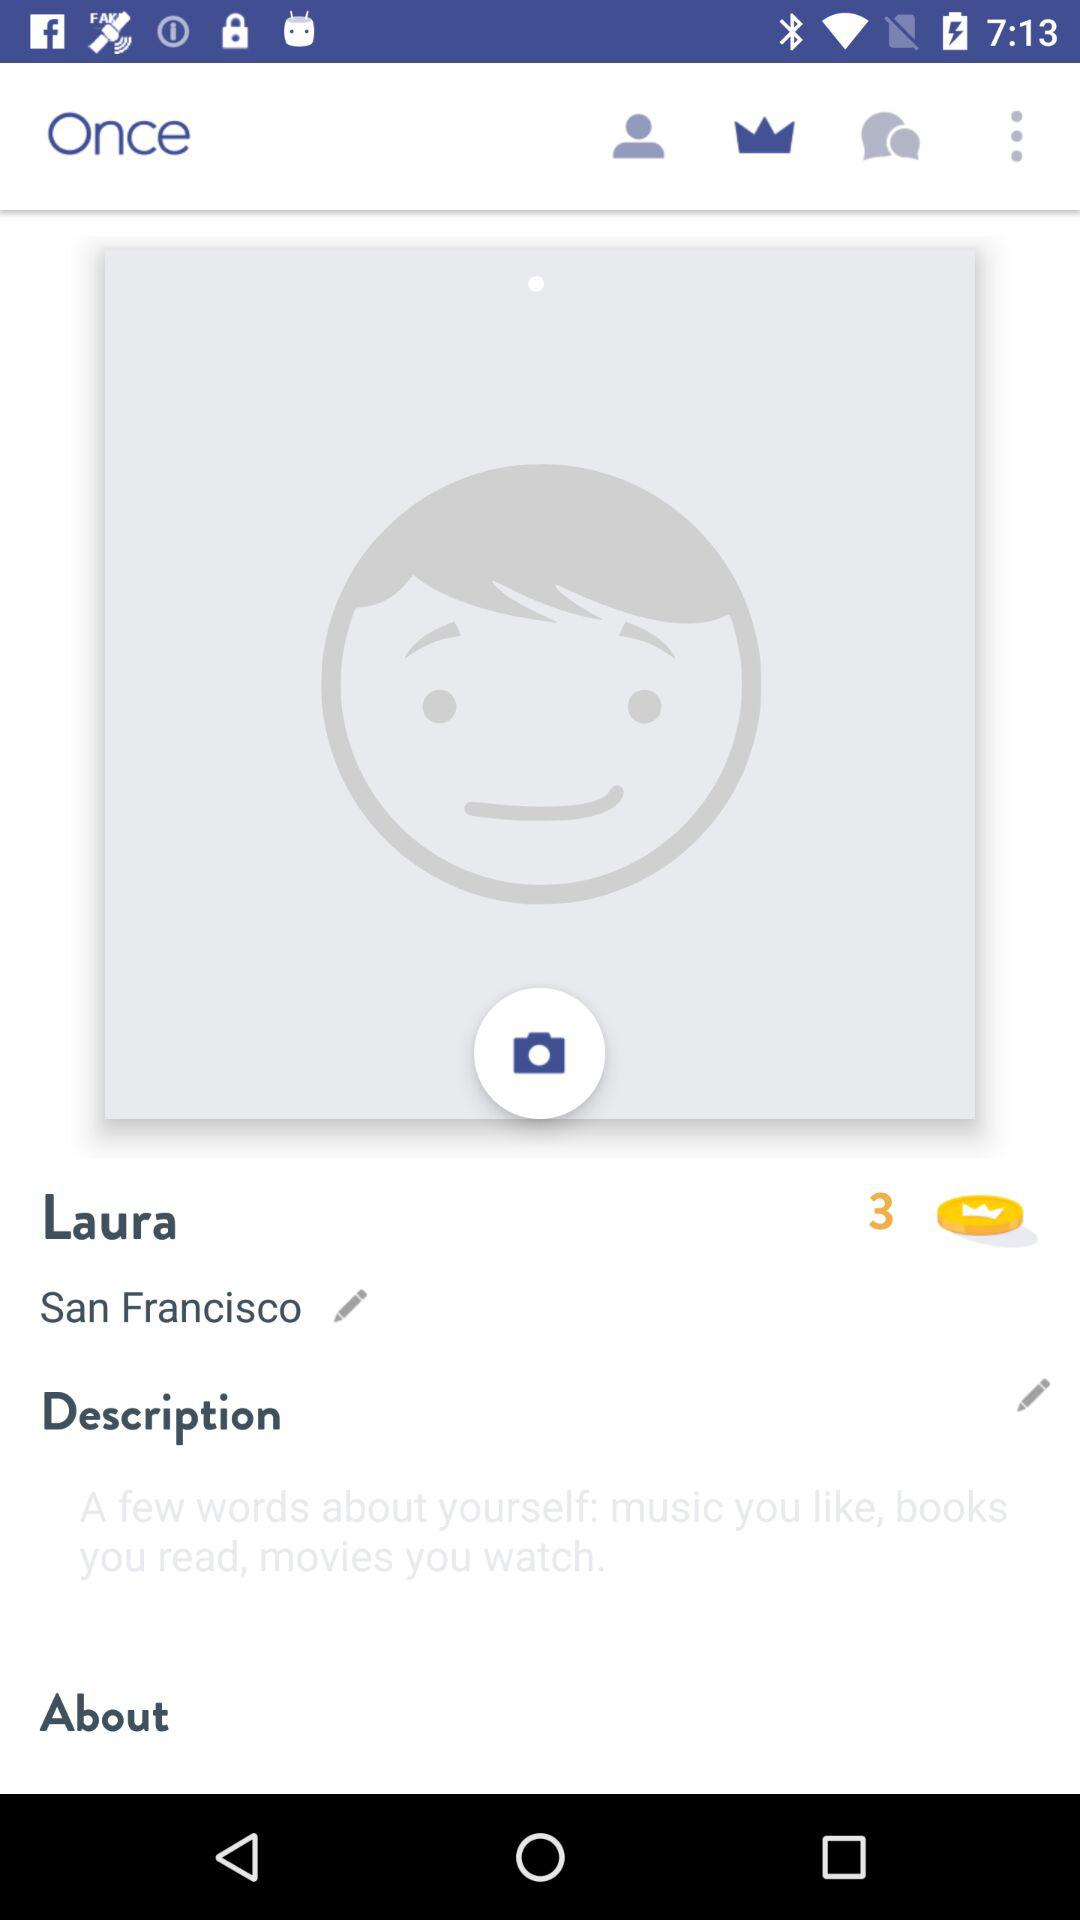Which place does Laura live? Laura lives in San Francisco. 